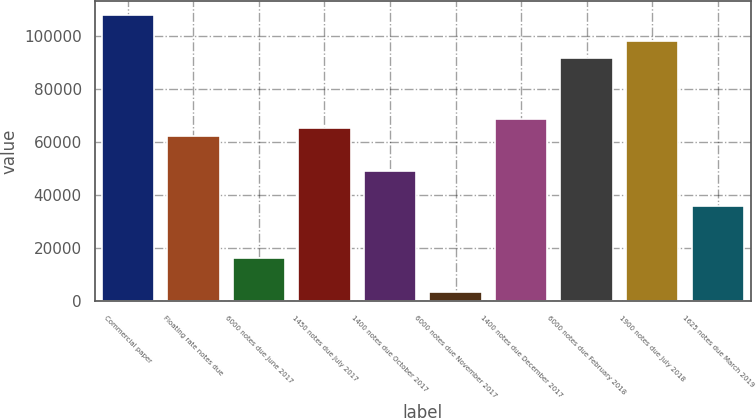Convert chart. <chart><loc_0><loc_0><loc_500><loc_500><bar_chart><fcel>Commercial paper<fcel>Floating rate notes due<fcel>6000 notes due June 2017<fcel>1450 notes due July 2017<fcel>1400 notes due October 2017<fcel>6000 notes due November 2017<fcel>1400 notes due December 2017<fcel>6000 notes due February 2018<fcel>1900 notes due July 2018<fcel>1625 notes due March 2019<nl><fcel>108116<fcel>62253.1<fcel>16390.5<fcel>65529<fcel>49149.5<fcel>3286.9<fcel>68804.9<fcel>91736.2<fcel>98288<fcel>36045.9<nl></chart> 